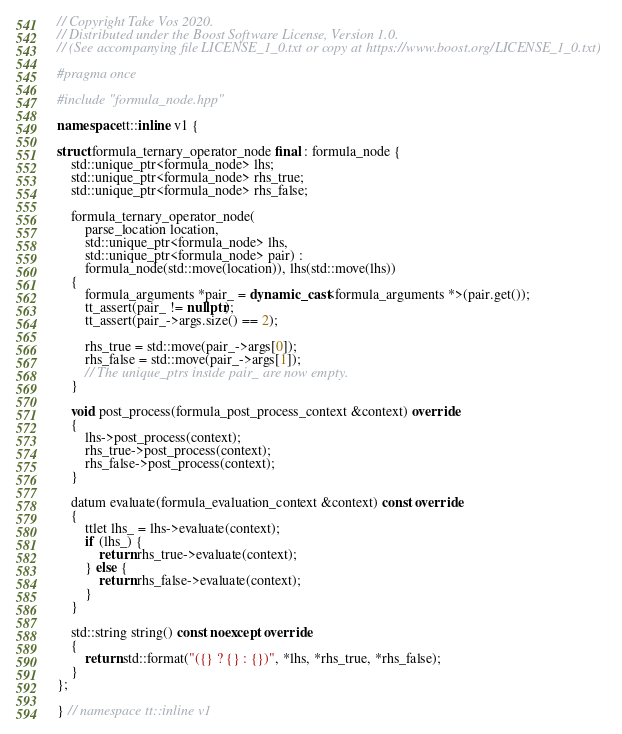<code> <loc_0><loc_0><loc_500><loc_500><_C++_>// Copyright Take Vos 2020.
// Distributed under the Boost Software License, Version 1.0.
// (See accompanying file LICENSE_1_0.txt or copy at https://www.boost.org/LICENSE_1_0.txt)

#pragma once

#include "formula_node.hpp"

namespace tt::inline v1 {

struct formula_ternary_operator_node final : formula_node {
    std::unique_ptr<formula_node> lhs;
    std::unique_ptr<formula_node> rhs_true;
    std::unique_ptr<formula_node> rhs_false;

    formula_ternary_operator_node(
        parse_location location,
        std::unique_ptr<formula_node> lhs,
        std::unique_ptr<formula_node> pair) :
        formula_node(std::move(location)), lhs(std::move(lhs))
    {
        formula_arguments *pair_ = dynamic_cast<formula_arguments *>(pair.get());
        tt_assert(pair_ != nullptr);
        tt_assert(pair_->args.size() == 2);

        rhs_true = std::move(pair_->args[0]);
        rhs_false = std::move(pair_->args[1]);
        // The unique_ptrs inside pair_ are now empty.
    }

    void post_process(formula_post_process_context &context) override
    {
        lhs->post_process(context);
        rhs_true->post_process(context);
        rhs_false->post_process(context);
    }

    datum evaluate(formula_evaluation_context &context) const override
    {
        ttlet lhs_ = lhs->evaluate(context);
        if (lhs_) {
            return rhs_true->evaluate(context);
        } else {
            return rhs_false->evaluate(context);
        }
    }

    std::string string() const noexcept override
    {
        return std::format("({} ? {} : {})", *lhs, *rhs_true, *rhs_false);
    }
};

} // namespace tt::inline v1</code> 